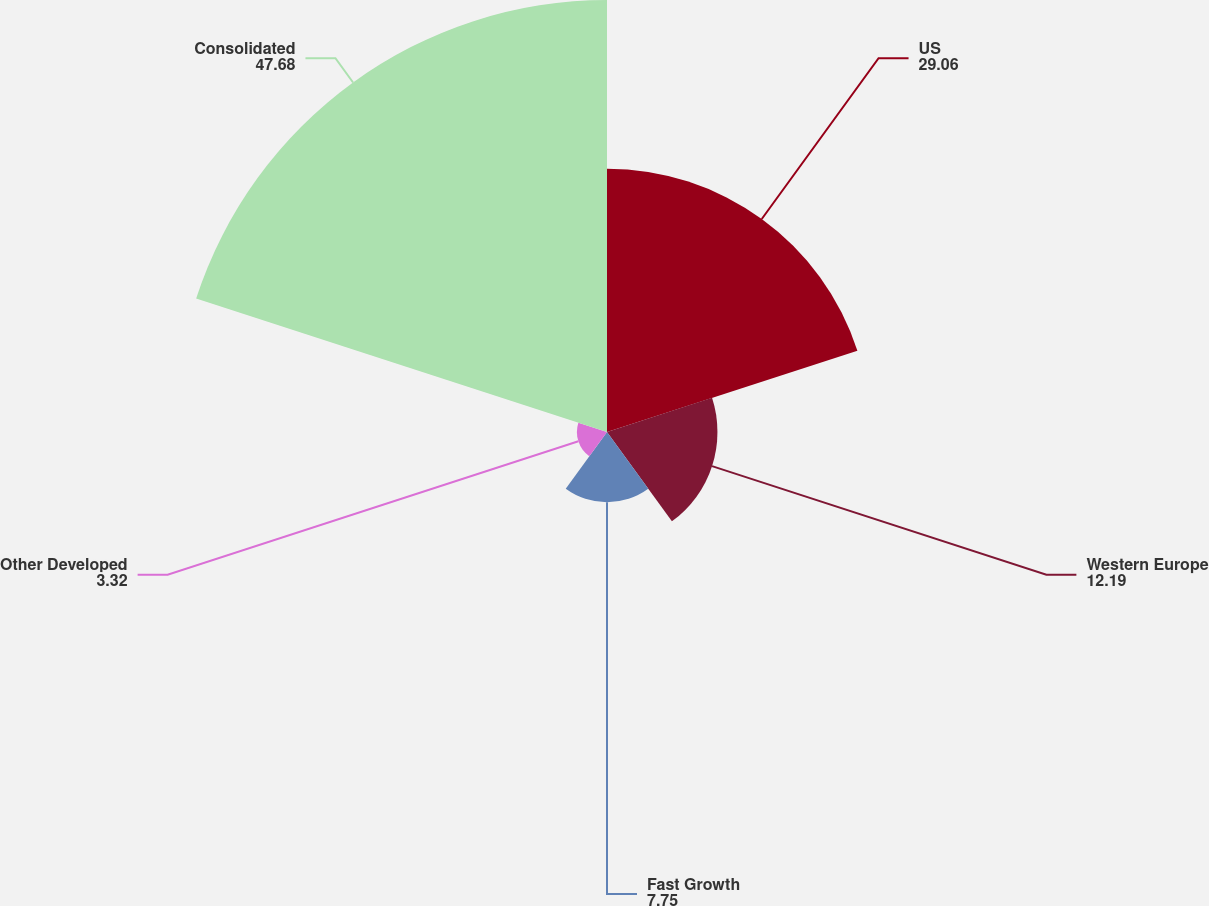<chart> <loc_0><loc_0><loc_500><loc_500><pie_chart><fcel>US<fcel>Western Europe<fcel>Fast Growth<fcel>Other Developed<fcel>Consolidated<nl><fcel>29.06%<fcel>12.19%<fcel>7.75%<fcel>3.32%<fcel>47.68%<nl></chart> 